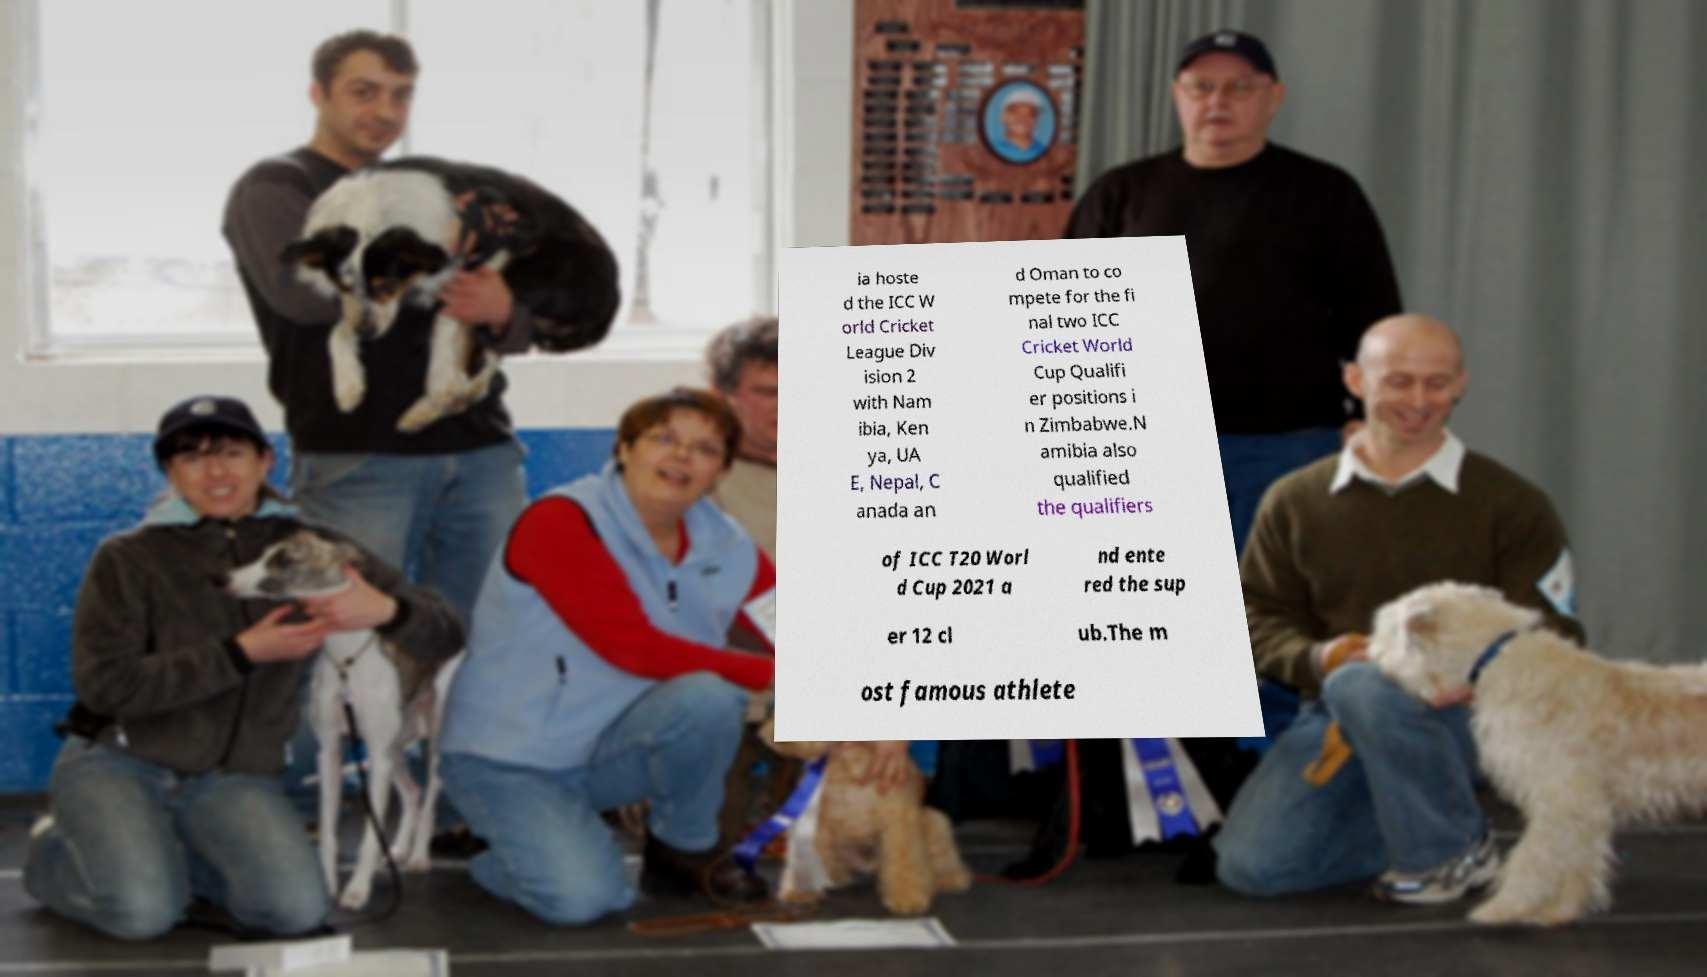Can you accurately transcribe the text from the provided image for me? ia hoste d the ICC W orld Cricket League Div ision 2 with Nam ibia, Ken ya, UA E, Nepal, C anada an d Oman to co mpete for the fi nal two ICC Cricket World Cup Qualifi er positions i n Zimbabwe.N amibia also qualified the qualifiers of ICC T20 Worl d Cup 2021 a nd ente red the sup er 12 cl ub.The m ost famous athlete 